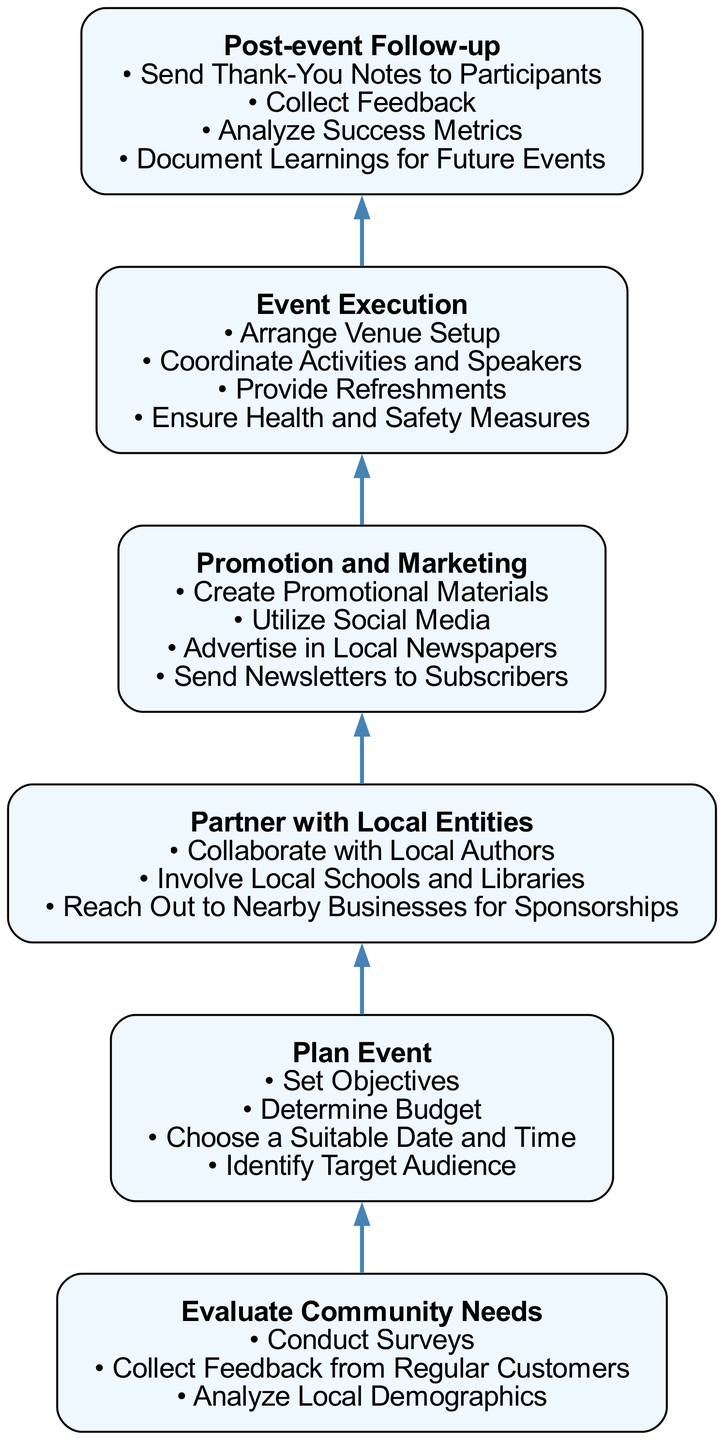What is the first step in organizing community events? The first step is "Evaluate Community Needs." This is the bottom node of the flow chart, indicating it is the starting point of the process.
Answer: Evaluate Community Needs How many details are provided for the "Plan Event" step? There are four details listed under the "Plan Event" step. These details include setting objectives, determining budget, choosing a suitable date and time, and identifying target audience.
Answer: 4 What step comes after "Promotion and Marketing"? The step that comes after "Promotion and Marketing" is "Event Execution." This can be determined by looking at the flow and identifying the next node above "Promotion and Marketing."
Answer: Event Execution Which step involves collaboration with local authors? Collaboration with local authors occurs in the "Partner with Local Entities" step. This is noted as one of the details listed under that node.
Answer: Partner with Local Entities What is the purpose of the "Post-event Follow-up" step? The purpose of the "Post-event Follow-up" step is to assess the success of the event and gather insights for future improvements. This includes sending thank you notes, collecting feedback, analyzing metrics, and documenting learnings, which are all mentioned in its details.
Answer: Assess success and gather insights How does "Plan Event" relate to "Event Execution"? "Plan Event" is a prerequisite to "Event Execution," meaning that an event must be planned before it can be executed. This relationship illustrates a sequential flow where planning informs the execution.
Answer: Prerequisite relationship What is the last step in the process outlined by the diagram? The last step in the process is "Post-event Follow-up." As this is the topmost node in the flow, it is the final action taken after executing the event.
Answer: Post-event Follow-up Which steps contain promotional activities? The steps that contain promotional activities are "Promotion and Marketing" and "Partner with Local Entities," as these involve creating promotional materials and leveraging local collaborations to attract more attendees.
Answer: Promotion and Marketing, Partner with Local Entities What should be considered when choosing a date and time for the event? When choosing a date and time for the event, it's essential to consider the target audience, as noted in the "Plan Event" step. This ensures that the event is scheduled when the intended audience is available to attend.
Answer: Target audience availability 